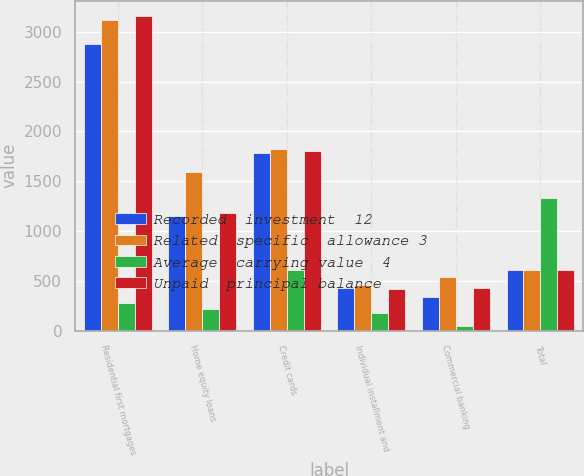Convert chart. <chart><loc_0><loc_0><loc_500><loc_500><stacked_bar_chart><ecel><fcel>Residential first mortgages<fcel>Home equity loans<fcel>Credit cards<fcel>Individual installment and<fcel>Commercial banking<fcel>Total<nl><fcel>Recorded  investment  12<fcel>2877<fcel>1151<fcel>1787<fcel>431<fcel>334<fcel>614<nl><fcel>Related  specific  allowance 3<fcel>3121<fcel>1590<fcel>1819<fcel>460<fcel>541<fcel>614<nl><fcel>Average  carrying value  4<fcel>278<fcel>216<fcel>614<fcel>175<fcel>51<fcel>1334<nl><fcel>Unpaid  principal balance<fcel>3155<fcel>1181<fcel>1803<fcel>415<fcel>429<fcel>614<nl></chart> 